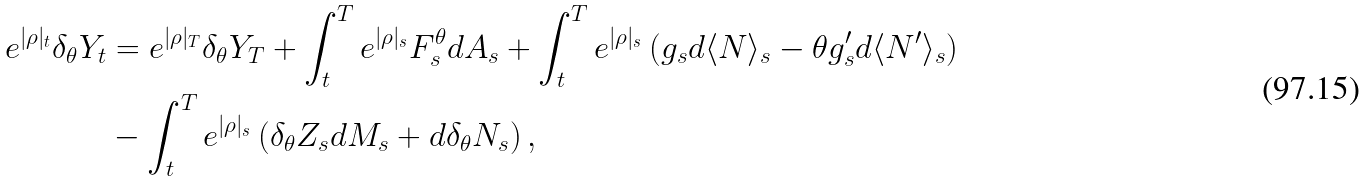<formula> <loc_0><loc_0><loc_500><loc_500>e ^ { | \rho | _ { t } } \delta _ { \theta } Y _ { t } & = e ^ { | \rho | _ { T } } \delta _ { \theta } Y _ { T } + \int _ { t } ^ { T } e ^ { | \rho | _ { s } } F ^ { \theta } _ { s } d A _ { s } + \int _ { t } ^ { T } e ^ { | \rho | _ { s } } \left ( g _ { s } d \langle N \rangle _ { s } - \theta g ^ { \prime } _ { s } d \langle N ^ { \prime } \rangle _ { s } \right ) \\ & - \int _ { t } ^ { T } e ^ { | \rho | _ { s } } \left ( \delta _ { \theta } Z _ { s } d M _ { s } + d \delta _ { \theta } N _ { s } \right ) ,</formula> 